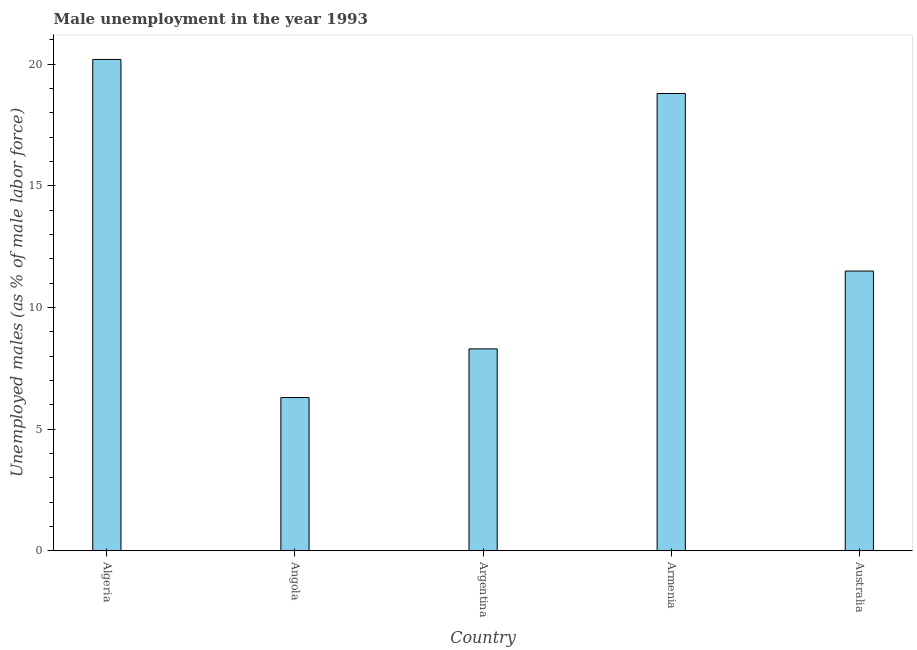Does the graph contain any zero values?
Make the answer very short. No. What is the title of the graph?
Your answer should be compact. Male unemployment in the year 1993. What is the label or title of the Y-axis?
Make the answer very short. Unemployed males (as % of male labor force). What is the unemployed males population in Algeria?
Offer a very short reply. 20.2. Across all countries, what is the maximum unemployed males population?
Your response must be concise. 20.2. Across all countries, what is the minimum unemployed males population?
Your response must be concise. 6.3. In which country was the unemployed males population maximum?
Offer a terse response. Algeria. In which country was the unemployed males population minimum?
Your answer should be compact. Angola. What is the sum of the unemployed males population?
Keep it short and to the point. 65.1. What is the difference between the unemployed males population in Angola and Australia?
Ensure brevity in your answer.  -5.2. What is the average unemployed males population per country?
Make the answer very short. 13.02. What is the median unemployed males population?
Provide a succinct answer. 11.5. What is the ratio of the unemployed males population in Argentina to that in Armenia?
Ensure brevity in your answer.  0.44. Is the unemployed males population in Algeria less than that in Argentina?
Give a very brief answer. No. In how many countries, is the unemployed males population greater than the average unemployed males population taken over all countries?
Your answer should be very brief. 2. How many bars are there?
Provide a succinct answer. 5. How many countries are there in the graph?
Keep it short and to the point. 5. Are the values on the major ticks of Y-axis written in scientific E-notation?
Offer a very short reply. No. What is the Unemployed males (as % of male labor force) in Algeria?
Offer a very short reply. 20.2. What is the Unemployed males (as % of male labor force) of Angola?
Ensure brevity in your answer.  6.3. What is the Unemployed males (as % of male labor force) in Argentina?
Your response must be concise. 8.3. What is the Unemployed males (as % of male labor force) of Armenia?
Make the answer very short. 18.8. What is the Unemployed males (as % of male labor force) in Australia?
Keep it short and to the point. 11.5. What is the difference between the Unemployed males (as % of male labor force) in Algeria and Argentina?
Make the answer very short. 11.9. What is the difference between the Unemployed males (as % of male labor force) in Algeria and Armenia?
Provide a short and direct response. 1.4. What is the difference between the Unemployed males (as % of male labor force) in Angola and Argentina?
Give a very brief answer. -2. What is the difference between the Unemployed males (as % of male labor force) in Angola and Armenia?
Your answer should be compact. -12.5. What is the difference between the Unemployed males (as % of male labor force) in Argentina and Australia?
Provide a short and direct response. -3.2. What is the ratio of the Unemployed males (as % of male labor force) in Algeria to that in Angola?
Your answer should be compact. 3.21. What is the ratio of the Unemployed males (as % of male labor force) in Algeria to that in Argentina?
Ensure brevity in your answer.  2.43. What is the ratio of the Unemployed males (as % of male labor force) in Algeria to that in Armenia?
Provide a succinct answer. 1.07. What is the ratio of the Unemployed males (as % of male labor force) in Algeria to that in Australia?
Provide a short and direct response. 1.76. What is the ratio of the Unemployed males (as % of male labor force) in Angola to that in Argentina?
Provide a succinct answer. 0.76. What is the ratio of the Unemployed males (as % of male labor force) in Angola to that in Armenia?
Ensure brevity in your answer.  0.34. What is the ratio of the Unemployed males (as % of male labor force) in Angola to that in Australia?
Make the answer very short. 0.55. What is the ratio of the Unemployed males (as % of male labor force) in Argentina to that in Armenia?
Provide a short and direct response. 0.44. What is the ratio of the Unemployed males (as % of male labor force) in Argentina to that in Australia?
Your answer should be very brief. 0.72. What is the ratio of the Unemployed males (as % of male labor force) in Armenia to that in Australia?
Offer a terse response. 1.64. 